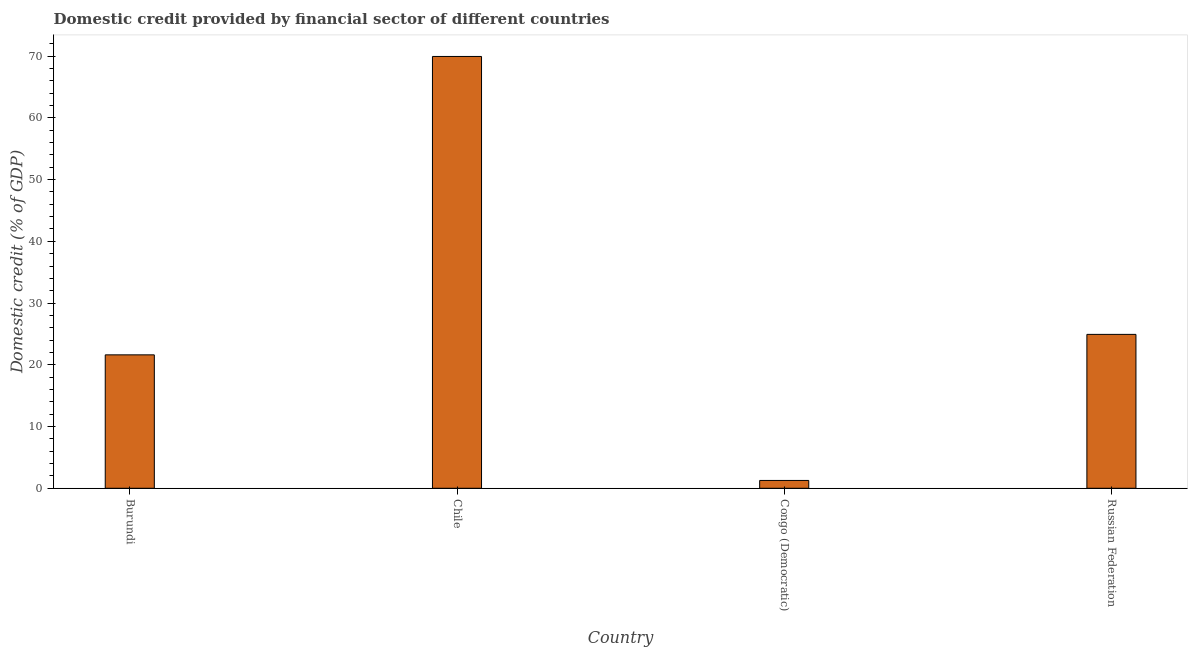Does the graph contain grids?
Your answer should be very brief. No. What is the title of the graph?
Provide a short and direct response. Domestic credit provided by financial sector of different countries. What is the label or title of the Y-axis?
Give a very brief answer. Domestic credit (% of GDP). What is the domestic credit provided by financial sector in Chile?
Ensure brevity in your answer.  69.94. Across all countries, what is the maximum domestic credit provided by financial sector?
Give a very brief answer. 69.94. Across all countries, what is the minimum domestic credit provided by financial sector?
Your answer should be compact. 1.27. In which country was the domestic credit provided by financial sector maximum?
Give a very brief answer. Chile. In which country was the domestic credit provided by financial sector minimum?
Ensure brevity in your answer.  Congo (Democratic). What is the sum of the domestic credit provided by financial sector?
Ensure brevity in your answer.  117.75. What is the difference between the domestic credit provided by financial sector in Burundi and Congo (Democratic)?
Offer a very short reply. 20.34. What is the average domestic credit provided by financial sector per country?
Offer a very short reply. 29.44. What is the median domestic credit provided by financial sector?
Your answer should be very brief. 23.27. What is the ratio of the domestic credit provided by financial sector in Congo (Democratic) to that in Russian Federation?
Ensure brevity in your answer.  0.05. Is the domestic credit provided by financial sector in Burundi less than that in Chile?
Your response must be concise. Yes. Is the difference between the domestic credit provided by financial sector in Chile and Congo (Democratic) greater than the difference between any two countries?
Keep it short and to the point. Yes. What is the difference between the highest and the second highest domestic credit provided by financial sector?
Make the answer very short. 45.02. Is the sum of the domestic credit provided by financial sector in Burundi and Chile greater than the maximum domestic credit provided by financial sector across all countries?
Your answer should be very brief. Yes. What is the difference between the highest and the lowest domestic credit provided by financial sector?
Make the answer very short. 68.67. In how many countries, is the domestic credit provided by financial sector greater than the average domestic credit provided by financial sector taken over all countries?
Your response must be concise. 1. What is the difference between two consecutive major ticks on the Y-axis?
Ensure brevity in your answer.  10. What is the Domestic credit (% of GDP) in Burundi?
Give a very brief answer. 21.61. What is the Domestic credit (% of GDP) in Chile?
Offer a terse response. 69.94. What is the Domestic credit (% of GDP) of Congo (Democratic)?
Keep it short and to the point. 1.27. What is the Domestic credit (% of GDP) in Russian Federation?
Keep it short and to the point. 24.93. What is the difference between the Domestic credit (% of GDP) in Burundi and Chile?
Offer a very short reply. -48.33. What is the difference between the Domestic credit (% of GDP) in Burundi and Congo (Democratic)?
Your answer should be very brief. 20.34. What is the difference between the Domestic credit (% of GDP) in Burundi and Russian Federation?
Give a very brief answer. -3.32. What is the difference between the Domestic credit (% of GDP) in Chile and Congo (Democratic)?
Keep it short and to the point. 68.67. What is the difference between the Domestic credit (% of GDP) in Chile and Russian Federation?
Offer a very short reply. 45.02. What is the difference between the Domestic credit (% of GDP) in Congo (Democratic) and Russian Federation?
Your response must be concise. -23.66. What is the ratio of the Domestic credit (% of GDP) in Burundi to that in Chile?
Your response must be concise. 0.31. What is the ratio of the Domestic credit (% of GDP) in Burundi to that in Congo (Democratic)?
Offer a terse response. 17.04. What is the ratio of the Domestic credit (% of GDP) in Burundi to that in Russian Federation?
Offer a very short reply. 0.87. What is the ratio of the Domestic credit (% of GDP) in Chile to that in Congo (Democratic)?
Offer a terse response. 55.16. What is the ratio of the Domestic credit (% of GDP) in Chile to that in Russian Federation?
Keep it short and to the point. 2.81. What is the ratio of the Domestic credit (% of GDP) in Congo (Democratic) to that in Russian Federation?
Offer a very short reply. 0.05. 